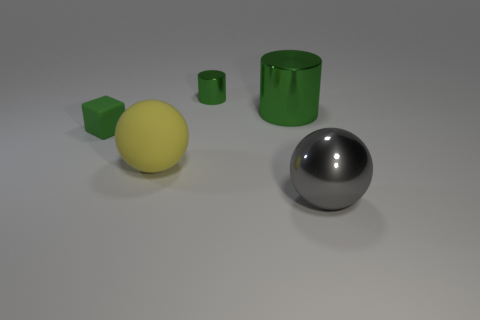There is a thing that is left of the yellow rubber ball; what material is it?
Offer a very short reply. Rubber. The metallic thing that is in front of the large shiny thing that is behind the metallic object that is in front of the large yellow thing is what color?
Give a very brief answer. Gray. There is a metal sphere that is the same size as the rubber ball; what is its color?
Ensure brevity in your answer.  Gray. What number of matte objects are either gray balls or balls?
Offer a terse response. 1. There is a tiny object that is the same material as the large cylinder; what is its color?
Give a very brief answer. Green. There is a sphere that is behind the ball that is right of the small cylinder; what is its material?
Your answer should be compact. Rubber. How many things are large metal objects on the left side of the gray thing or big objects in front of the small green block?
Give a very brief answer. 3. What size is the shiny object in front of the tiny green object on the left side of the tiny green object that is behind the big green thing?
Your answer should be compact. Large. Are there the same number of green shiny cylinders that are on the left side of the small shiny cylinder and large blue rubber cylinders?
Provide a short and direct response. Yes. Is there any other thing that is the same shape as the big gray object?
Offer a terse response. Yes. 